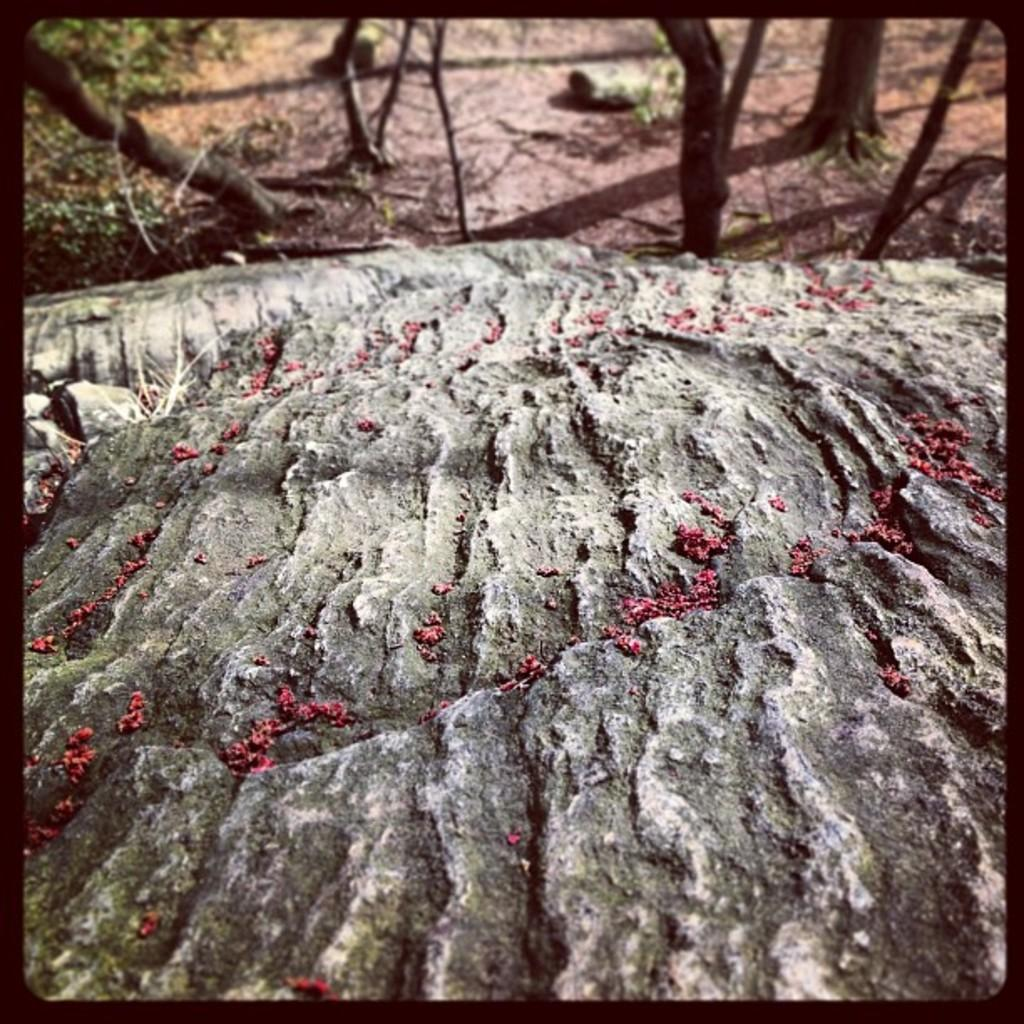What is located at the bottom of the image? There are seeds on a rock at the bottom of the image. What can be seen in the background of the image? There are trees, a rock, plants, and sticks on the ground in the background of the image. What type of button is being used to plant the seeds in the image? There is no button present in the image; the seeds are on a rock. How does the image convey a sense of hate or dislike? The image does not convey any sense of hate or dislike; it is a neutral depiction of seeds, rocks, and background elements. 